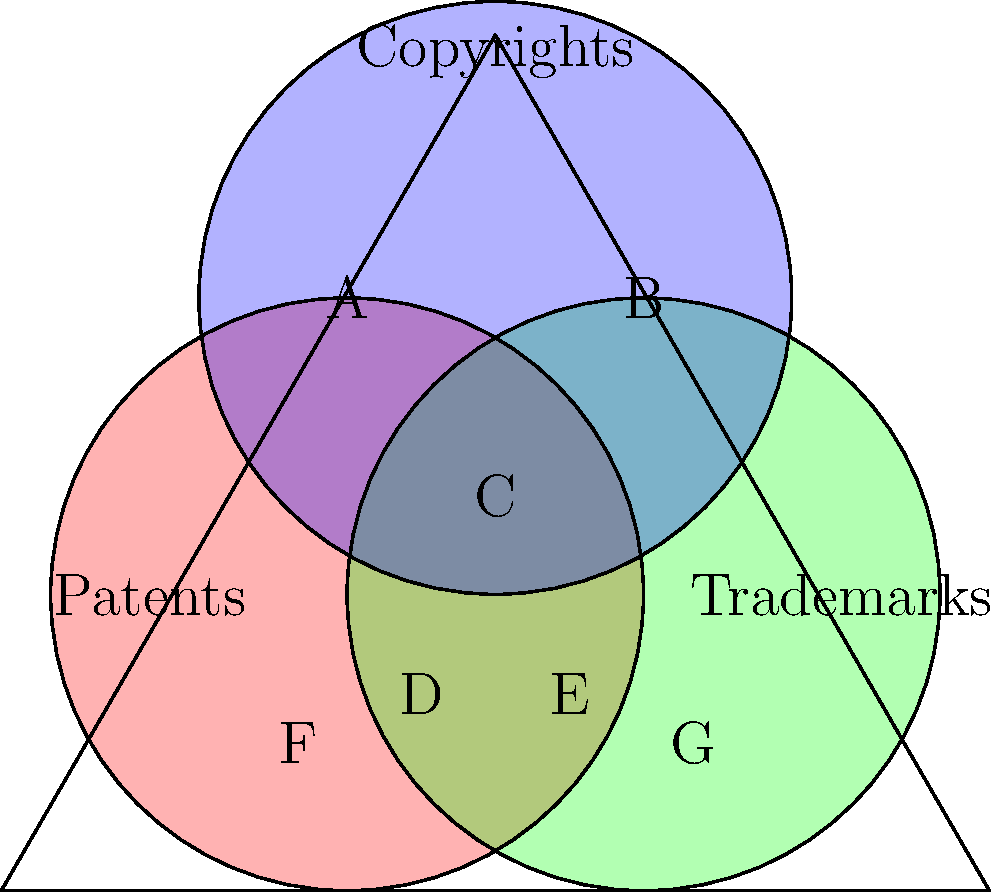In the Venn diagram above, which represents the overlap of different types of intellectual property rights, how many distinct regions are formed by the intersection of patents, trademarks, and copyrights? To determine the number of distinct regions in the Venn diagram, we need to systematically count each area:

1. Region A: Copyrights only
2. Region B: Copyrights and Trademarks (not Patents)
3. Region C: All three (Patents, Trademarks, and Copyrights)
4. Region D: Patents and Copyrights (not Trademarks)
5. Region E: Patents and Trademarks (not Copyrights)
6. Region F: Patents only
7. Region G: Trademarks only

Additionally, there is one more region:
8. The area outside all three circles, representing items not protected by any of these intellectual property rights.

Therefore, the total number of distinct regions formed by the intersection of patents, trademarks, and copyrights is 8.

This Venn diagram illustrates the complex relationships between different forms of intellectual property protection, which is crucial in technology-related legal cases. As a retired court judge with experience in such cases, understanding these distinctions and overlaps is essential for accurate legal interpretation and decision-making.
Answer: 8 regions 